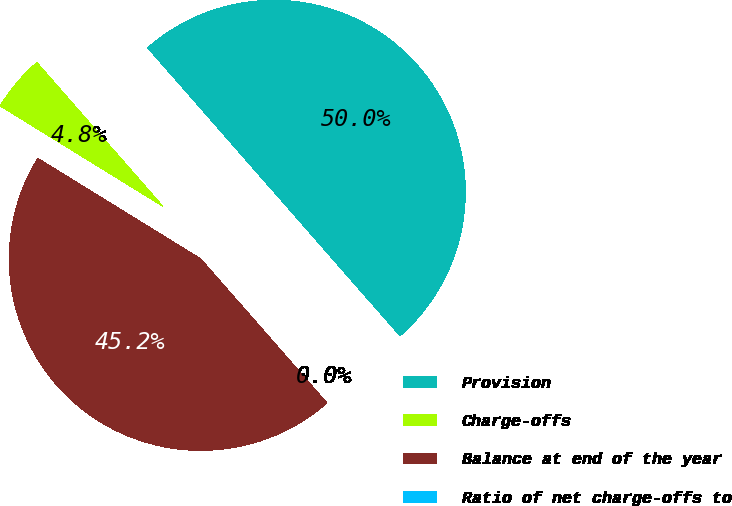<chart> <loc_0><loc_0><loc_500><loc_500><pie_chart><fcel>Provision<fcel>Charge-offs<fcel>Balance at end of the year<fcel>Ratio of net charge-offs to<nl><fcel>50.0%<fcel>4.75%<fcel>45.25%<fcel>0.0%<nl></chart> 